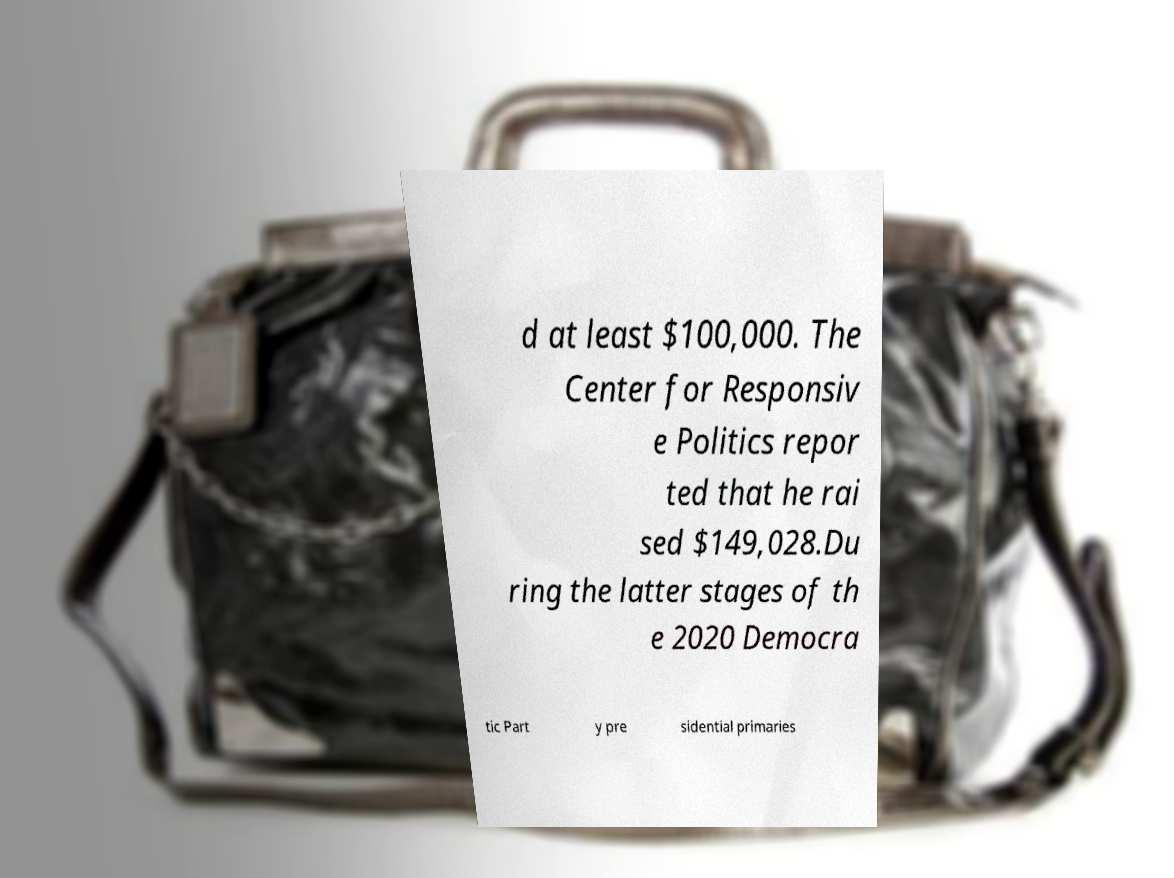There's text embedded in this image that I need extracted. Can you transcribe it verbatim? d at least $100,000. The Center for Responsiv e Politics repor ted that he rai sed $149,028.Du ring the latter stages of th e 2020 Democra tic Part y pre sidential primaries 